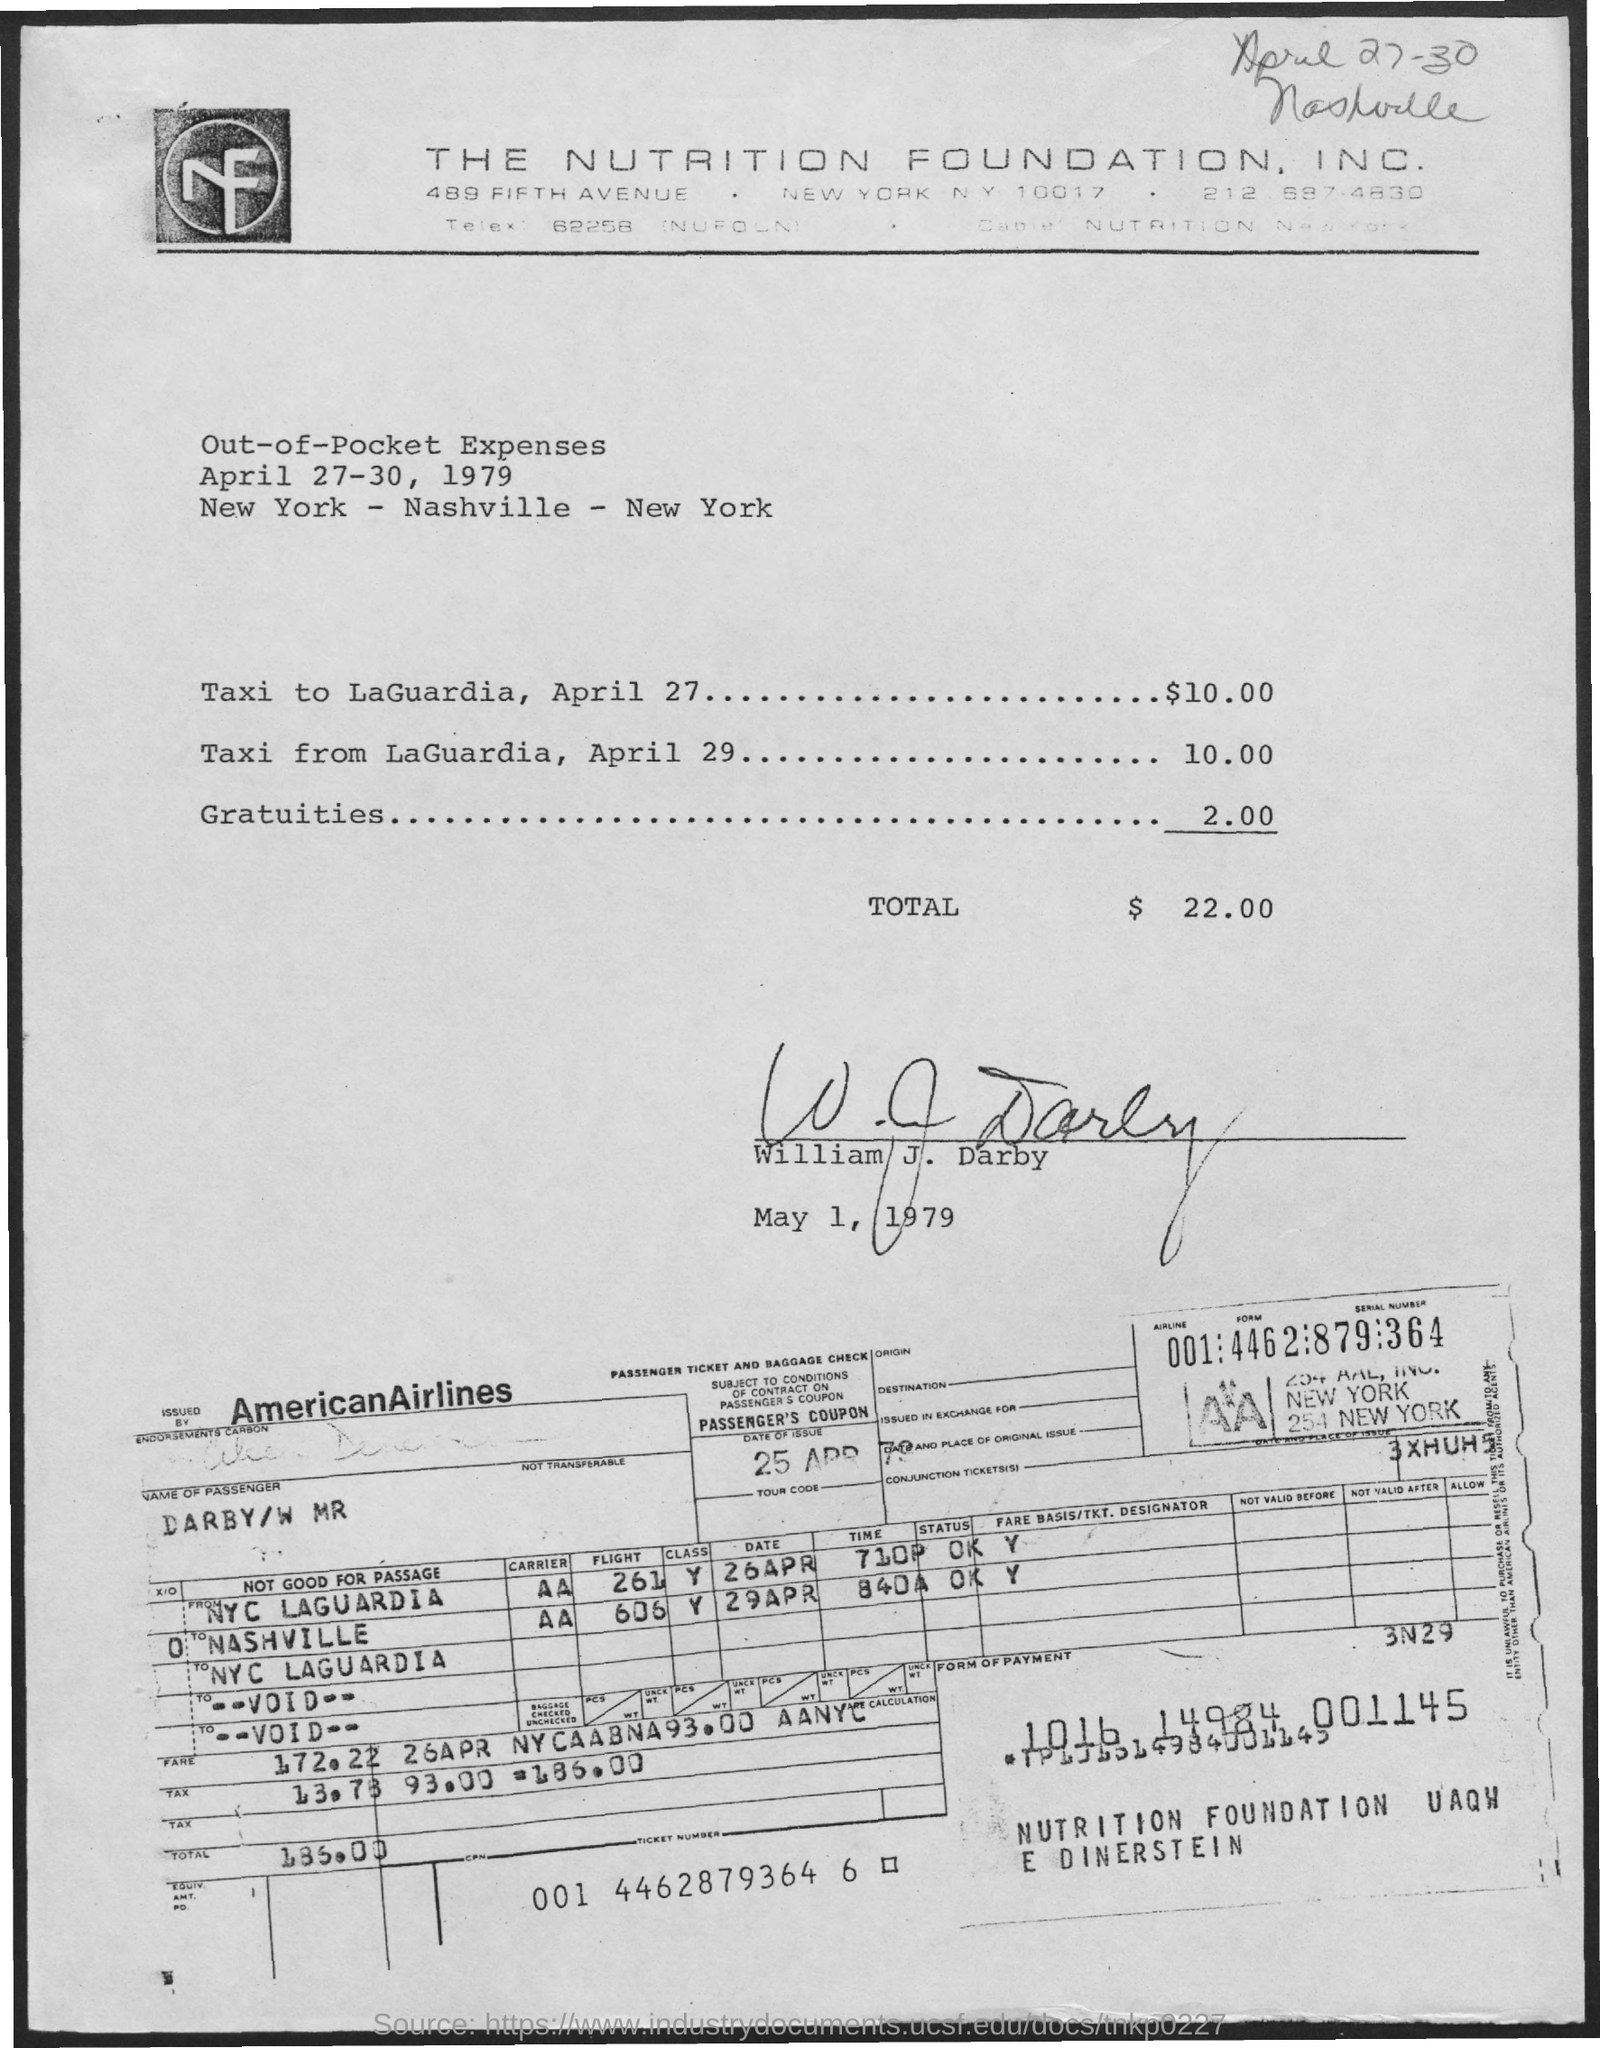Mention a couple of crucial points in this snapshot. American Airlines will be providing the airline ticket. 